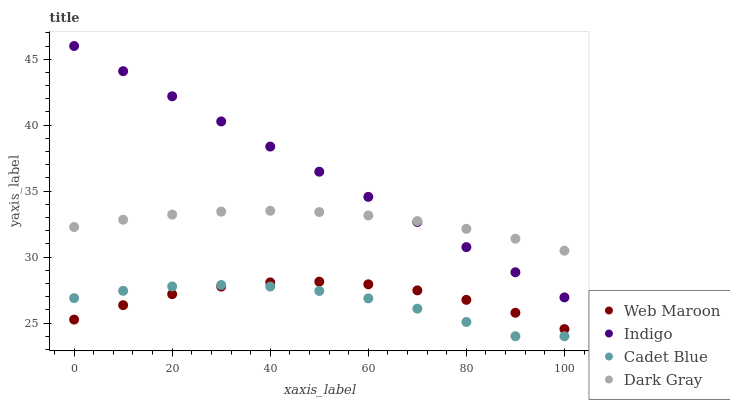Does Cadet Blue have the minimum area under the curve?
Answer yes or no. Yes. Does Indigo have the maximum area under the curve?
Answer yes or no. Yes. Does Indigo have the minimum area under the curve?
Answer yes or no. No. Does Cadet Blue have the maximum area under the curve?
Answer yes or no. No. Is Indigo the smoothest?
Answer yes or no. Yes. Is Cadet Blue the roughest?
Answer yes or no. Yes. Is Cadet Blue the smoothest?
Answer yes or no. No. Is Indigo the roughest?
Answer yes or no. No. Does Cadet Blue have the lowest value?
Answer yes or no. Yes. Does Indigo have the lowest value?
Answer yes or no. No. Does Indigo have the highest value?
Answer yes or no. Yes. Does Cadet Blue have the highest value?
Answer yes or no. No. Is Web Maroon less than Dark Gray?
Answer yes or no. Yes. Is Dark Gray greater than Web Maroon?
Answer yes or no. Yes. Does Indigo intersect Dark Gray?
Answer yes or no. Yes. Is Indigo less than Dark Gray?
Answer yes or no. No. Is Indigo greater than Dark Gray?
Answer yes or no. No. Does Web Maroon intersect Dark Gray?
Answer yes or no. No. 